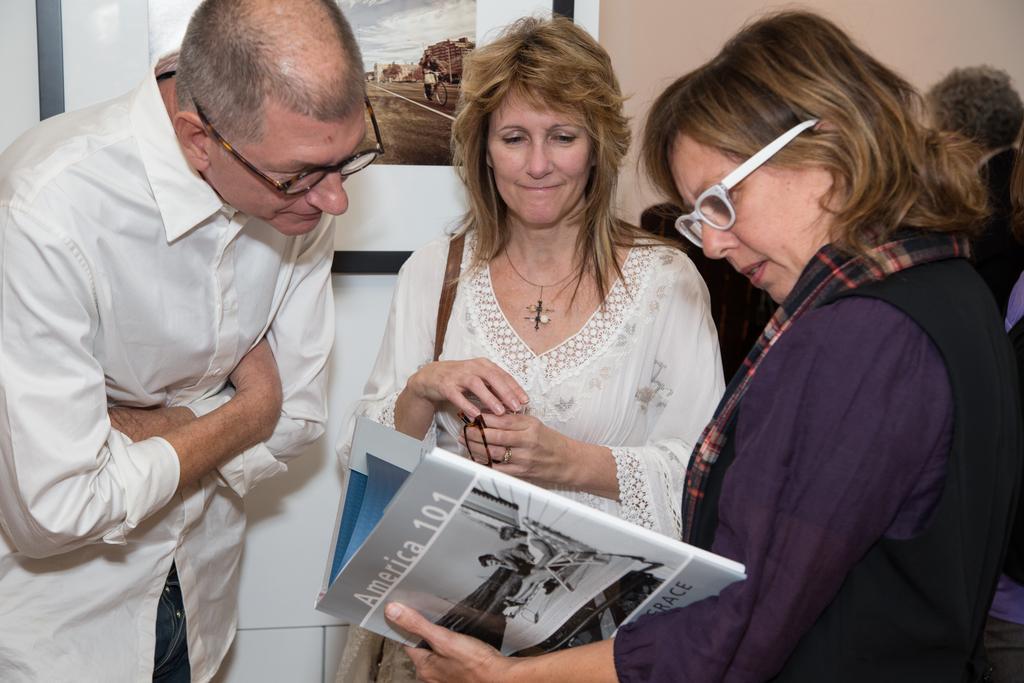Could you give a brief overview of what you see in this image? In the picture we can see group of people standing, there is woman who is holding some book in her hands and in the background there is photo frame which is attached to the wall. 